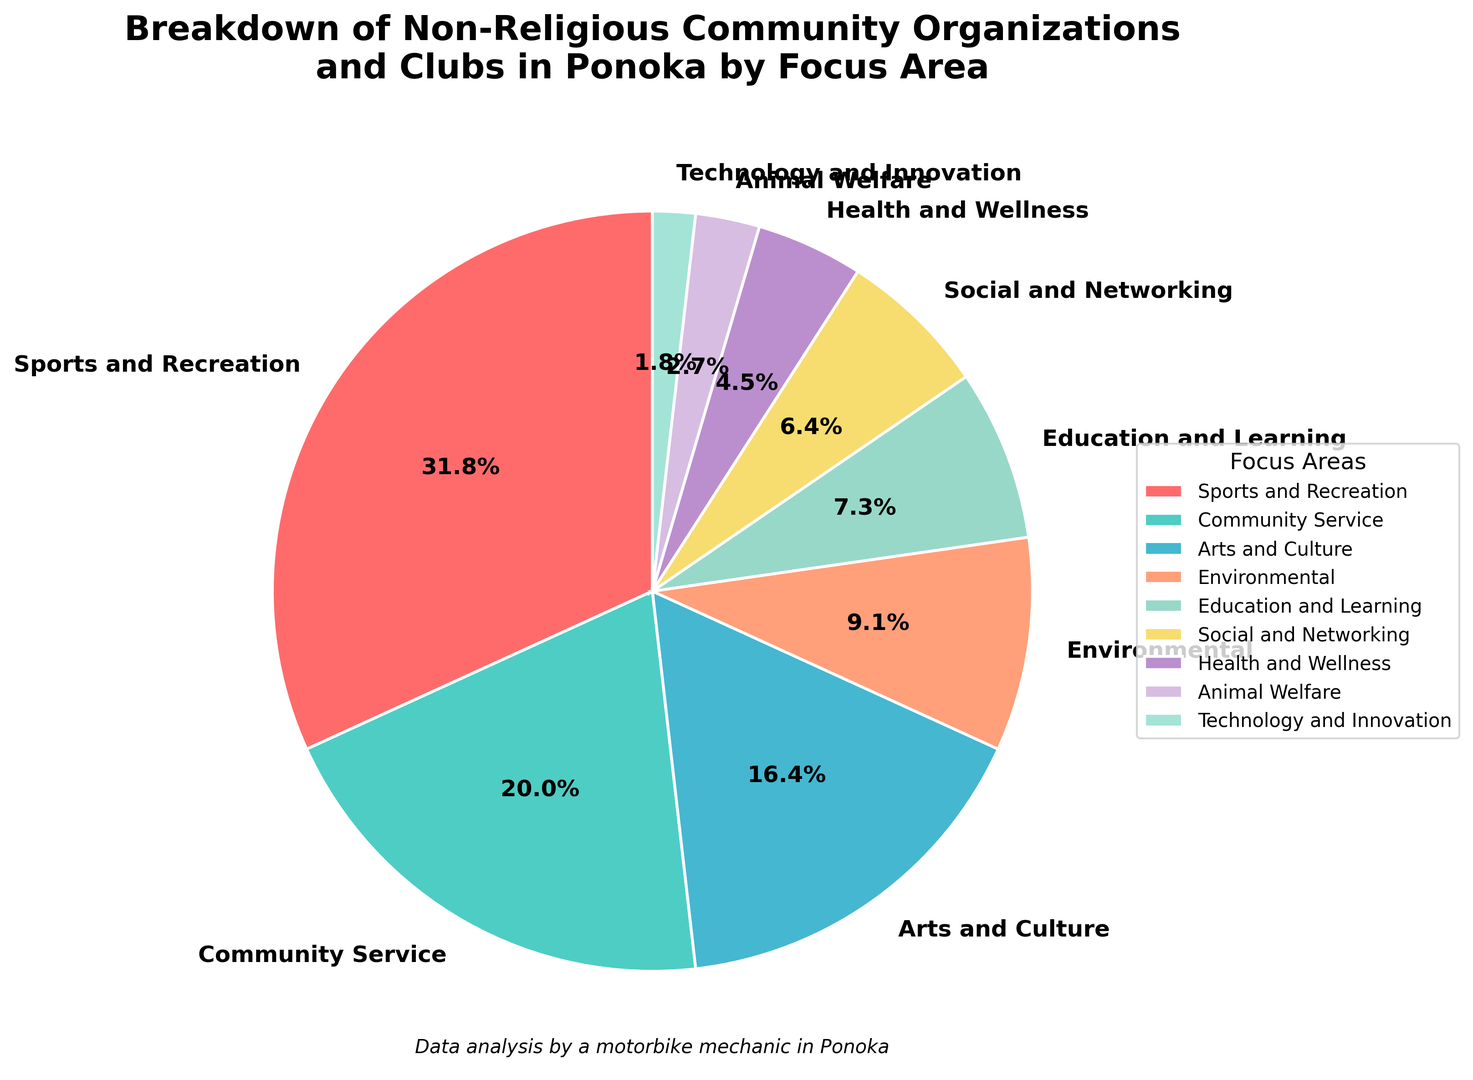What percentage of the non-religious community organizations in Ponoka focus on health and wellness? Locate the Health and Wellness segment on the pie chart and read the percentage label given.
Answer: 5% Which focus area constitutes the largest proportion of non-religious community organizations in Ponoka? Identify the sector with the largest slice on the pie chart and read the label.
Answer: Sports and Recreation How does the percentage of community service organizations compare to those focusing on education and learning? Find and compare the percentages for Community Service and Education and Learning on the pie chart. Community Service is 22% while Education and Learning is 8%, so Community Service is greater.
Answer: Community Service is greater What is the combined percentage of organizations focusing on Arts and Culture and Environmental issues? Add the percentages for Arts and Culture (18%) and Environmental (10%) on the pie chart.
Answer: 28% Are there more Technology and Innovation clubs or Animal Welfare clubs? Compare the two sections for Technology and Innovation (2%) and Animal Welfare (3%) on the pie chart.
Answer: Animal Welfare Which focus area has the second least representation in non-religious community organizations in Ponoka? After identifying the smallest segment (Technology and Innovation), find the one with the next smallest size, which is Animal Welfare (3%).
Answer: Animal Welfare How much greater is the percentage of organizations focused on Sports and Recreation compared to Health and Wellness? Subtract Health and Wellness percentage (5%) from Sports and Recreation percentage (35%).
Answer: 30% If a new organization focused on Technology and Innovation was added, what would be the new total percentage for this focus area? Add 1% to the current Technology and Innovation percentage (2%) to account for the new organization.
Answer: 3% What is the difference in percentage between the largest and smallest focus areas? Identify the largest slice (Sports and Recreation, 35%) and the smallest slice (Technology and Innovation, 2%) and find the difference by subtracting the smaller from the larger.
Answer: 33% What combined percentage do the focus areas with percentages below 10% represent? Add the percentages of Environmental (10%), Social and Networking (7%), Health and Wellness (5%), Animal Welfare (3%), and Technology and Innovation (2%). Calculating the total: 10 + 7 + 5 + 3 + 2 = 27.
Answer: 27% 